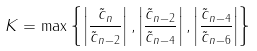<formula> <loc_0><loc_0><loc_500><loc_500>K = \max \left \{ \left | \frac { \tilde { c } _ { n } } { \tilde { c } _ { n - 2 } } \right | , \left | \frac { \tilde { c } _ { n - 2 } } { \tilde { c } _ { n - 4 } } \right | , \left | \frac { \tilde { c } _ { n - 4 } } { \tilde { c } _ { n - 6 } } \right | \right \}</formula> 